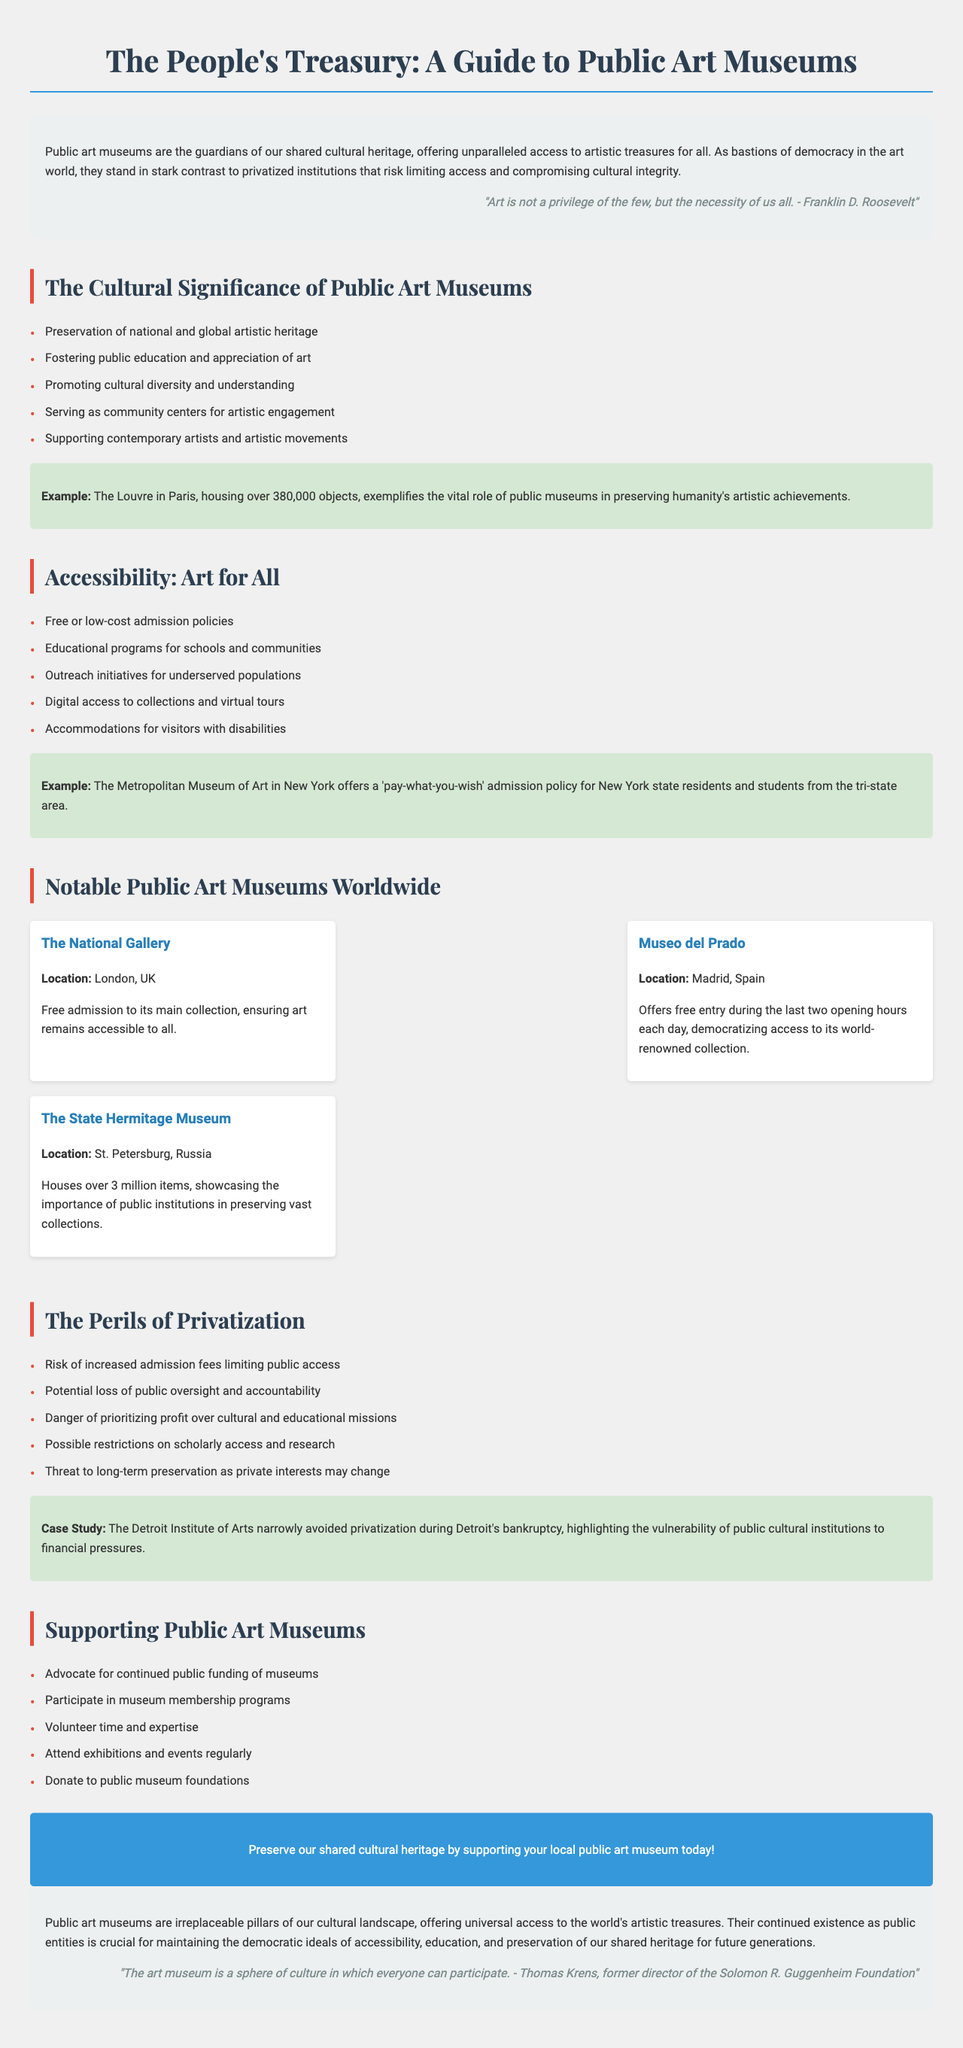What is the title of the brochure? The title is stated at the top of the document and identifies the subject of the brochure.
Answer: The People's Treasury: A Guide to Public Art Museums Who is quoted in the introduction? The introduction includes a quote from a notable figure, which emphasizes the importance of art for all.
Answer: Franklin D. Roosevelt What is one example of a notable public art museum mentioned? The notable museums section lists specific museums as examples of public art institutions around the world.
Answer: The National Gallery What are the two main themes of public art museums highlighted in the brochure? The document specifically addresses the cultural significance and accessibility aspects of public art museums.
Answer: Cultural significance and accessibility How many items does the State Hermitage Museum house? The document provides specific figures regarding the collections of different museums, including the State Hermitage Museum.
Answer: Over 3 million items What is one potential peril of privatization mentioned? The brochure discusses various risks associated with privatizing public art institutions, focusing on the consequences of such actions.
Answer: Increased admission fees What call to action is suggested for supporting public art museums? The document ends with a direct plea encouraging readers to engage in specific supportive actions for public museums.
Answer: Preserve our shared cultural heritage by supporting your local public art museum today! 